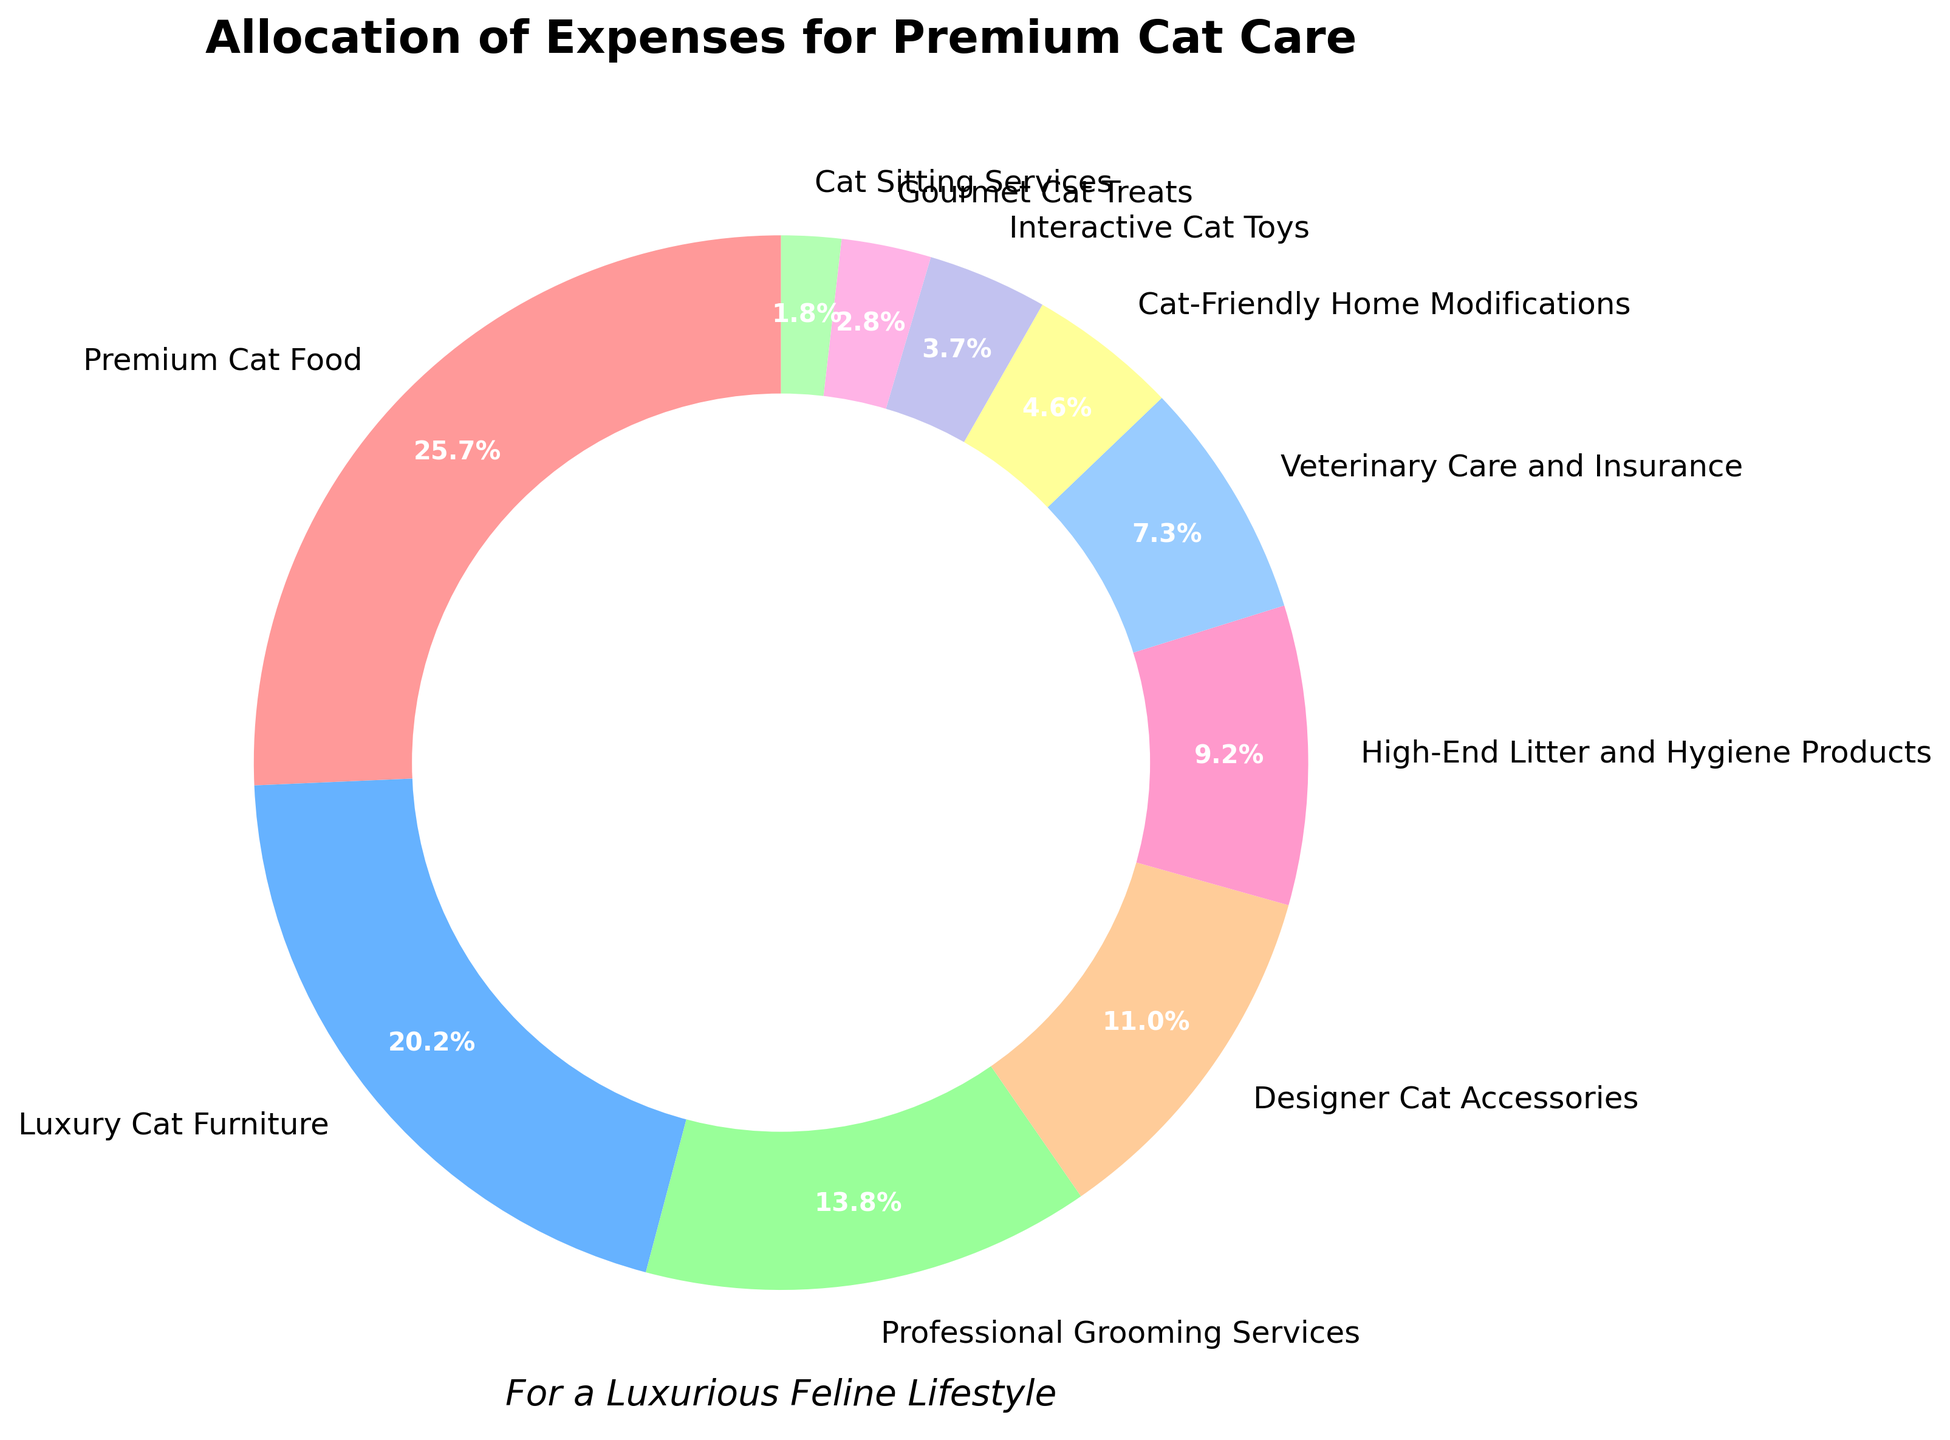What is the largest expense category? The largest segment in the pie chart represents the Premium Cat Food category, as it occupies the largest portion of the pie.
Answer: Premium Cat Food What percentage of the budget is spent on Veterinary Care and Insurance? The pie chart shows that the Veterinary Care and Insurance category makes up 8% of the total expenses.
Answer: 8% What is the combined percentage of expenses for Designer Cat Accessories and High-End Litter and Hygiene Products? The Designer Cat Accessories account for 12% and High-End Litter and Hygiene Products account for 10%. Summing these gives 12% + 10% = 22%.
Answer: 22% How does the expense for Luxury Cat Furniture compare to that for Professional Grooming Services? The pie chart shows that Luxury Cat Furniture accounts for 22% of the budget, whereas Professional Grooming Services account for 15%. Therefore, Luxury Cat Furniture expenses are greater than Professional Grooming Services by 7%.
Answer: Luxury Cat Furniture is 7% greater Which expense category has the smallest share, and what is its percentage? The smallest segment of the pie chart represents the Cat Sitting Services category, which makes up 2% of the total expenses.
Answer: Cat Sitting Services, 2% How much more is spent on Gourmet Cat Treats compared to Interactive Cat Toys? Interactive Cat Toys account for 4% and Gourmet Cat Treats account for 3%. Therefore, 4% - 3% = 1% more is spent on Interactive Cat Toys than Gourmet Cat Treats.
Answer: Interactive Cat Toys by 1% What is the total percentage spent on services (Professional Grooming Services and Cat Sitting Services)? Professional Grooming Services account for 15% and Cat Sitting Services account for 2%. Summing these gives 15% + 2% = 17%.
Answer: 17% What is the difference in spending between Premium Cat Food and Luxury Cat Furniture? Premium Cat Food accounts for 28% and Luxury Cat Furniture accounts for 22%. The difference is 28% - 22% = 6%.
Answer: 6% What portion of the budget is allocated to both high-end hygiene products and home modifications? High-End Litter and Hygiene Products are 10% and Cat-Friendly Home Modifications are 5%. Summing these gives 10% + 5% = 15%.
Answer: 15% Of the expenses shown, which category occupies a middle position in terms of its percentage share? By examining the pie chart, Designer Cat Accessories, with 12%, lies in the middle range compared to the others.
Answer: Designer Cat Accessories 